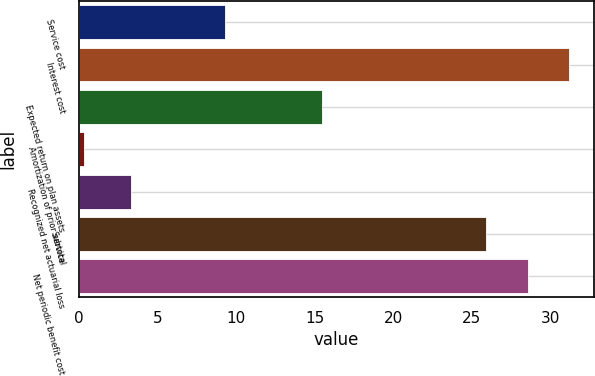<chart> <loc_0><loc_0><loc_500><loc_500><bar_chart><fcel>Service cost<fcel>Interest cost<fcel>Expected return on plan assets<fcel>Amortization of prior service<fcel>Recognized net actuarial loss<fcel>Subtotal<fcel>Net periodic benefit cost<nl><fcel>9.3<fcel>31.22<fcel>15.5<fcel>0.3<fcel>3.3<fcel>25.9<fcel>28.56<nl></chart> 